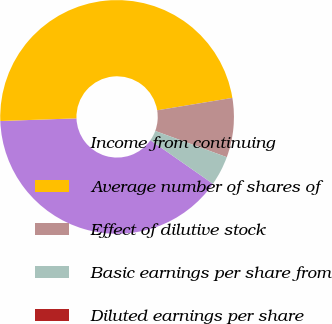<chart> <loc_0><loc_0><loc_500><loc_500><pie_chart><fcel>Income from continuing<fcel>Average number of shares of<fcel>Effect of dilutive stock<fcel>Basic earnings per share from<fcel>Diluted earnings per share<nl><fcel>39.75%<fcel>47.95%<fcel>8.2%<fcel>4.1%<fcel>0.0%<nl></chart> 